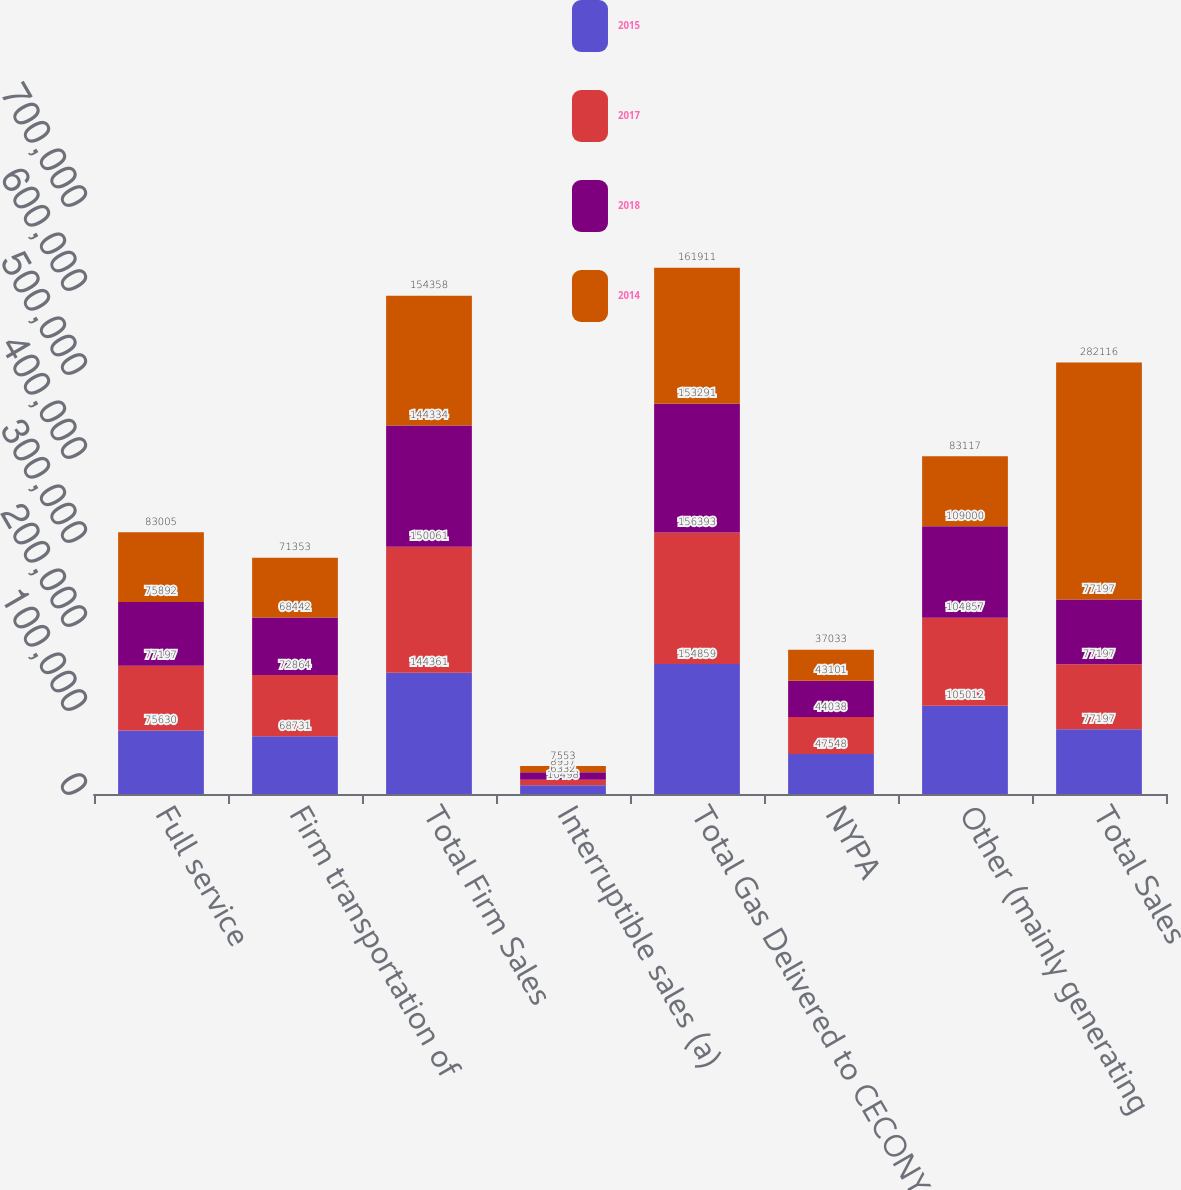Convert chart to OTSL. <chart><loc_0><loc_0><loc_500><loc_500><stacked_bar_chart><ecel><fcel>Full service<fcel>Firm transportation of<fcel>Total Firm Sales<fcel>Interruptible sales (a)<fcel>Total Gas Delivered to CECONY<fcel>NYPA<fcel>Other (mainly generating<fcel>Total Sales<nl><fcel>2015<fcel>75630<fcel>68731<fcel>144361<fcel>10498<fcel>154859<fcel>47548<fcel>105012<fcel>77197<nl><fcel>2017<fcel>77197<fcel>72864<fcel>150061<fcel>6332<fcel>156393<fcel>44038<fcel>104857<fcel>77197<nl><fcel>2018<fcel>75892<fcel>68442<fcel>144334<fcel>8957<fcel>153291<fcel>43101<fcel>109000<fcel>77197<nl><fcel>2014<fcel>83005<fcel>71353<fcel>154358<fcel>7553<fcel>161911<fcel>37033<fcel>83117<fcel>282116<nl></chart> 